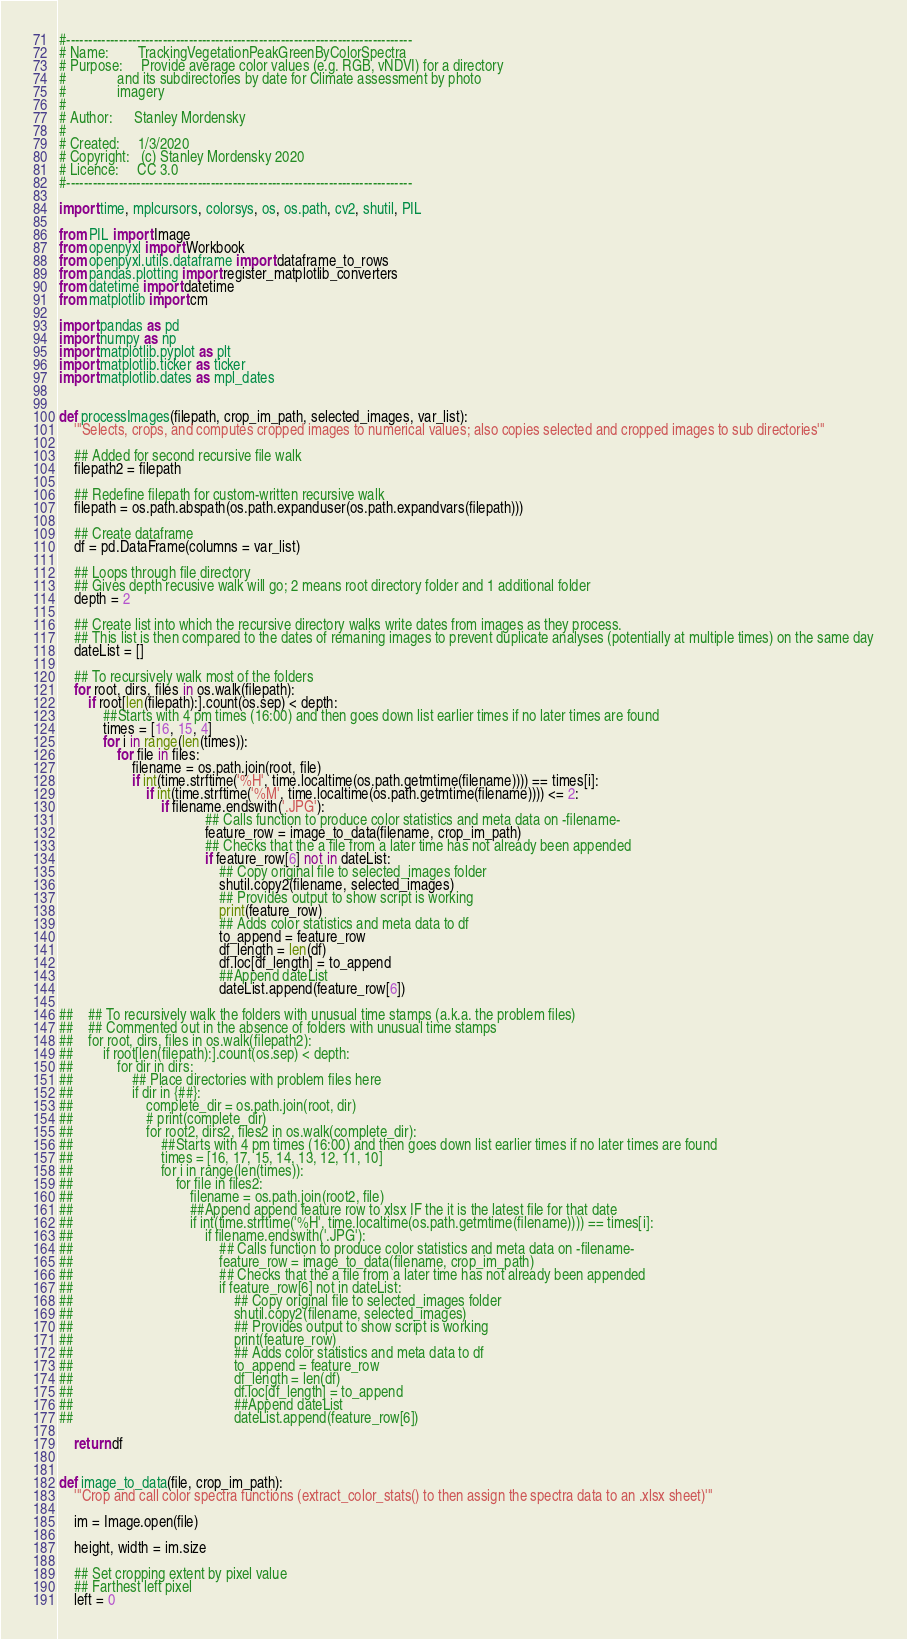Convert code to text. <code><loc_0><loc_0><loc_500><loc_500><_Python_>#-------------------------------------------------------------------------------
# Name:        TrackingVegetationPeakGreenByColorSpectra
# Purpose:     Provide average color values (e.g. RGB, vNDVI) for a directory
#              and its subdirectories by date for Climate assessment by photo
#              imagery
#
# Author:      Stanley Mordensky
#
# Created:     1/3/2020
# Copyright:   (c) Stanley Mordensky 2020
# Licence:     CC 3.0
#-------------------------------------------------------------------------------

import time, mplcursors, colorsys, os, os.path, cv2, shutil, PIL

from PIL import Image
from openpyxl import Workbook
from openpyxl.utils.dataframe import dataframe_to_rows
from pandas.plotting import register_matplotlib_converters
from datetime import datetime
from matplotlib import cm

import pandas as pd
import numpy as np
import matplotlib.pyplot as plt
import matplotlib.ticker as ticker
import matplotlib.dates as mpl_dates


def processImages(filepath, crop_im_path, selected_images, var_list):
    '''Selects, crops, and computes cropped images to numerical values; also copies selected and cropped images to sub directories'''

    ## Added for second recursive file walk
    filepath2 = filepath

    ## Redefine filepath for custom-written recursive walk
    filepath = os.path.abspath(os.path.expanduser(os.path.expandvars(filepath)))

    ## Create dataframe
    df = pd.DataFrame(columns = var_list)

    ## Loops through file directory
    ## Gives depth recusive walk will go; 2 means root directory folder and 1 additional folder
    depth = 2

    ## Create list into which the recursive directory walks write dates from images as they process.
    ## This list is then compared to the dates of remaning images to prevent duplicate analyses (potentially at multiple times) on the same day
    dateList = []

    ## To recursively walk most of the folders
    for root, dirs, files in os.walk(filepath):
        if root[len(filepath):].count(os.sep) < depth:
            ##Starts with 4 pm times (16:00) and then goes down list earlier times if no later times are found
            times = [16, 15, 4]
            for i in range(len(times)):
                for file in files:
                    filename = os.path.join(root, file)
                    if int(time.strftime('%H', time.localtime(os.path.getmtime(filename)))) == times[i]:
                        if int(time.strftime('%M', time.localtime(os.path.getmtime(filename)))) <= 2:
                            if filename.endswith('.JPG'):
                                        ## Calls function to produce color statistics and meta data on -filename-
                                        feature_row = image_to_data(filename, crop_im_path)
                                        ## Checks that the a file from a later time has not already been appended
                                        if feature_row[6] not in dateList:
                                            ## Copy original file to selected_images folder
                                            shutil.copy2(filename, selected_images)
                                            ## Provides output to show script is working
                                            print(feature_row)
                                            ## Adds color statistics and meta data to df
                                            to_append = feature_row
                                            df_length = len(df)
                                            df.loc[df_length] = to_append
                                            ##Append dateList
                                            dateList.append(feature_row[6])

##    ## To recursively walk the folders with unusual time stamps (a.k.a. the problem files)
##    ## Commented out in the absence of folders with unusual time stamps
##    for root, dirs, files in os.walk(filepath2):
##        if root[len(filepath):].count(os.sep) < depth:
##            for dir in dirs:
##                ## Place directories with problem files here
##                if dir in {##}:
##                    complete_dir = os.path.join(root, dir)
##                    # print(complete_dir)
##                    for root2, dirs2, files2 in os.walk(complete_dir):
##                        ##Starts with 4 pm times (16:00) and then goes down list earlier times if no later times are found
##                        times = [16, 17, 15, 14, 13, 12, 11, 10]
##                        for i in range(len(times)):
##                            for file in files2:
##                                filename = os.path.join(root2, file)
##                                ##Append append feature row to xlsx IF the it is the latest file for that date
##                                if int(time.strftime('%H', time.localtime(os.path.getmtime(filename)))) == times[i]:
##                                    if filename.endswith('.JPG'):
##                                        ## Calls function to produce color statistics and meta data on -filename-
##                                        feature_row = image_to_data(filename, crop_im_path)
##                                        ## Checks that the a file from a later time has not already been appended
##                                        if feature_row[6] not in dateList:
##                                            ## Copy original file to selected_images folder
##                                            shutil.copy2(filename, selected_images)
##                                            ## Provides output to show script is working
##                                            print(feature_row)
##                                            ## Adds color statistics and meta data to df
##                                            to_append = feature_row
##                                            df_length = len(df)
##                                            df.loc[df_length] = to_append
##                                            ##Append dateList
##                                            dateList.append(feature_row[6])

    return df


def image_to_data(file, crop_im_path):
    '''Crop and call color spectra functions (extract_color_stats() to then assign the spectra data to an .xlsx sheet)'''

    im = Image.open(file)

    height, width = im.size

    ## Set cropping extent by pixel value
    ## Farthest left pixel
    left = 0</code> 